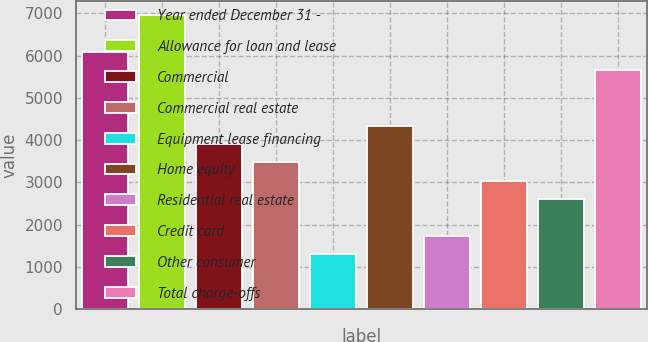<chart> <loc_0><loc_0><loc_500><loc_500><bar_chart><fcel>Year ended December 31 -<fcel>Allowance for loan and lease<fcel>Commercial<fcel>Commercial real estate<fcel>Equipment lease financing<fcel>Home equity<fcel>Residential real estate<fcel>Credit card<fcel>Other consumer<fcel>Total charge-offs<nl><fcel>6085.52<fcel>6954.8<fcel>3912.32<fcel>3477.68<fcel>1304.48<fcel>4346.96<fcel>1739.12<fcel>3043.04<fcel>2608.4<fcel>5650.88<nl></chart> 